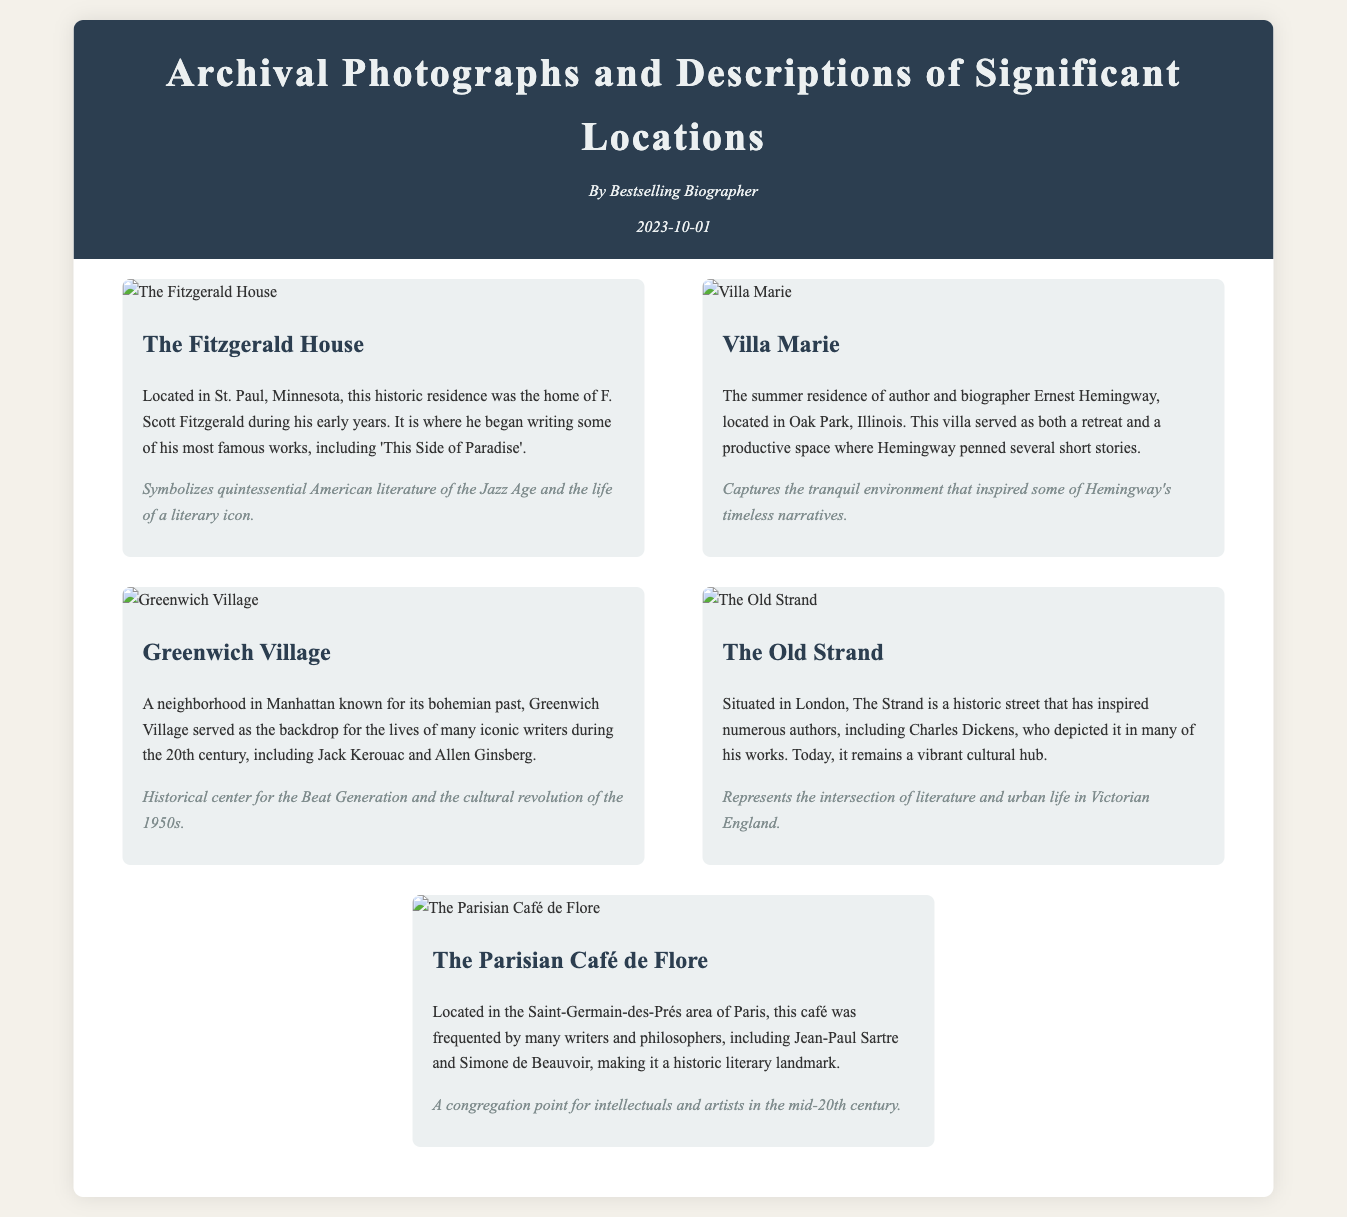What is the title of the document? The title is presented at the top of the document, identifying its main theme.
Answer: Archival Photographs and Descriptions of Significant Locations Who wrote the document? The author's name is mentioned in the header section of the document.
Answer: Bestselling Biographer What is the publication date of the document? The date of publication is displayed in the header.
Answer: 2023-10-01 How many entries are listed in the catalog? The number of entries can be counted in the catalog section of the document.
Answer: Five What significant location is described as the home of F. Scott Fitzgerald? The location is clearly identified in the entry regarding Fitzgerald's residence.
Answer: The Fitzgerald House What literary figure frequented the Café de Flore? The document mentions prominent figures associated with the café.
Answer: Jean-Paul Sartre Which location is known for being a cultural hub in Victorian England? This information can be deduced from the description provided in the corresponding entry.
Answer: The Old Strand What is the significance of Greenwich Village? The significance is stated in the description related to its historical context.
Answer: Historical center for the Beat Generation and the cultural revolution of the 1950s What type of document is this? The overall purpose and format define this as a catalog of photographs and descriptions.
Answer: Catalog 